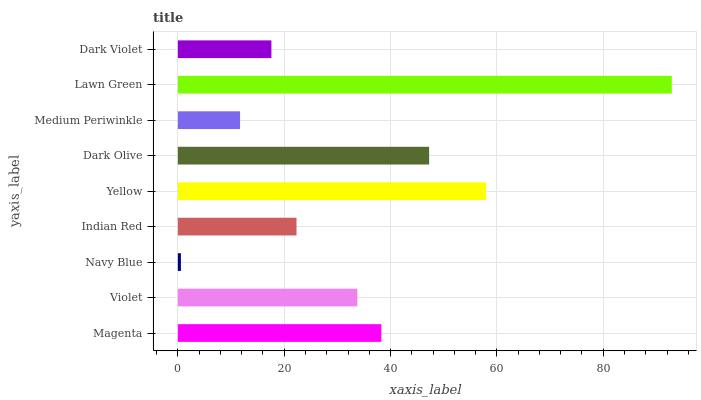Is Navy Blue the minimum?
Answer yes or no. Yes. Is Lawn Green the maximum?
Answer yes or no. Yes. Is Violet the minimum?
Answer yes or no. No. Is Violet the maximum?
Answer yes or no. No. Is Magenta greater than Violet?
Answer yes or no. Yes. Is Violet less than Magenta?
Answer yes or no. Yes. Is Violet greater than Magenta?
Answer yes or no. No. Is Magenta less than Violet?
Answer yes or no. No. Is Violet the high median?
Answer yes or no. Yes. Is Violet the low median?
Answer yes or no. Yes. Is Magenta the high median?
Answer yes or no. No. Is Dark Violet the low median?
Answer yes or no. No. 